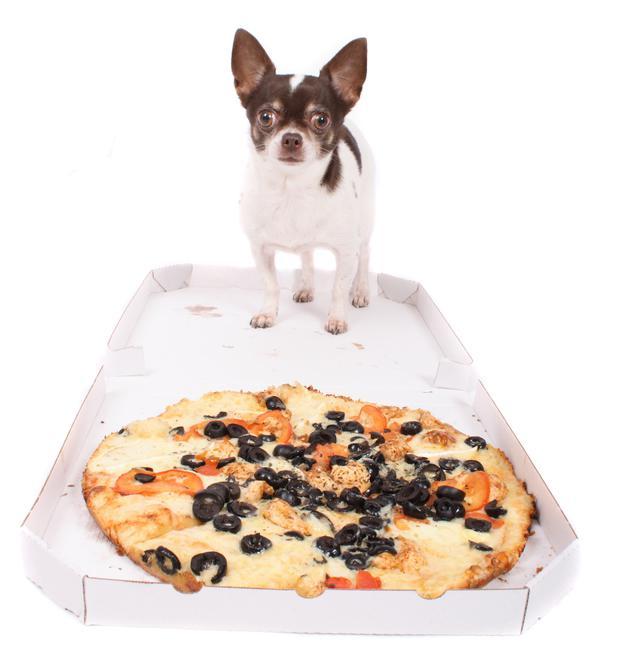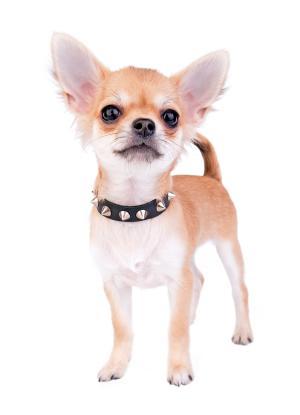The first image is the image on the left, the second image is the image on the right. Analyze the images presented: Is the assertion "Two dogs are shown standing near food." valid? Answer yes or no. No. The first image is the image on the left, the second image is the image on the right. Evaluate the accuracy of this statement regarding the images: "At least one image shows a single dog standing behind a white plate with multiple food items on it.". Is it true? Answer yes or no. No. 